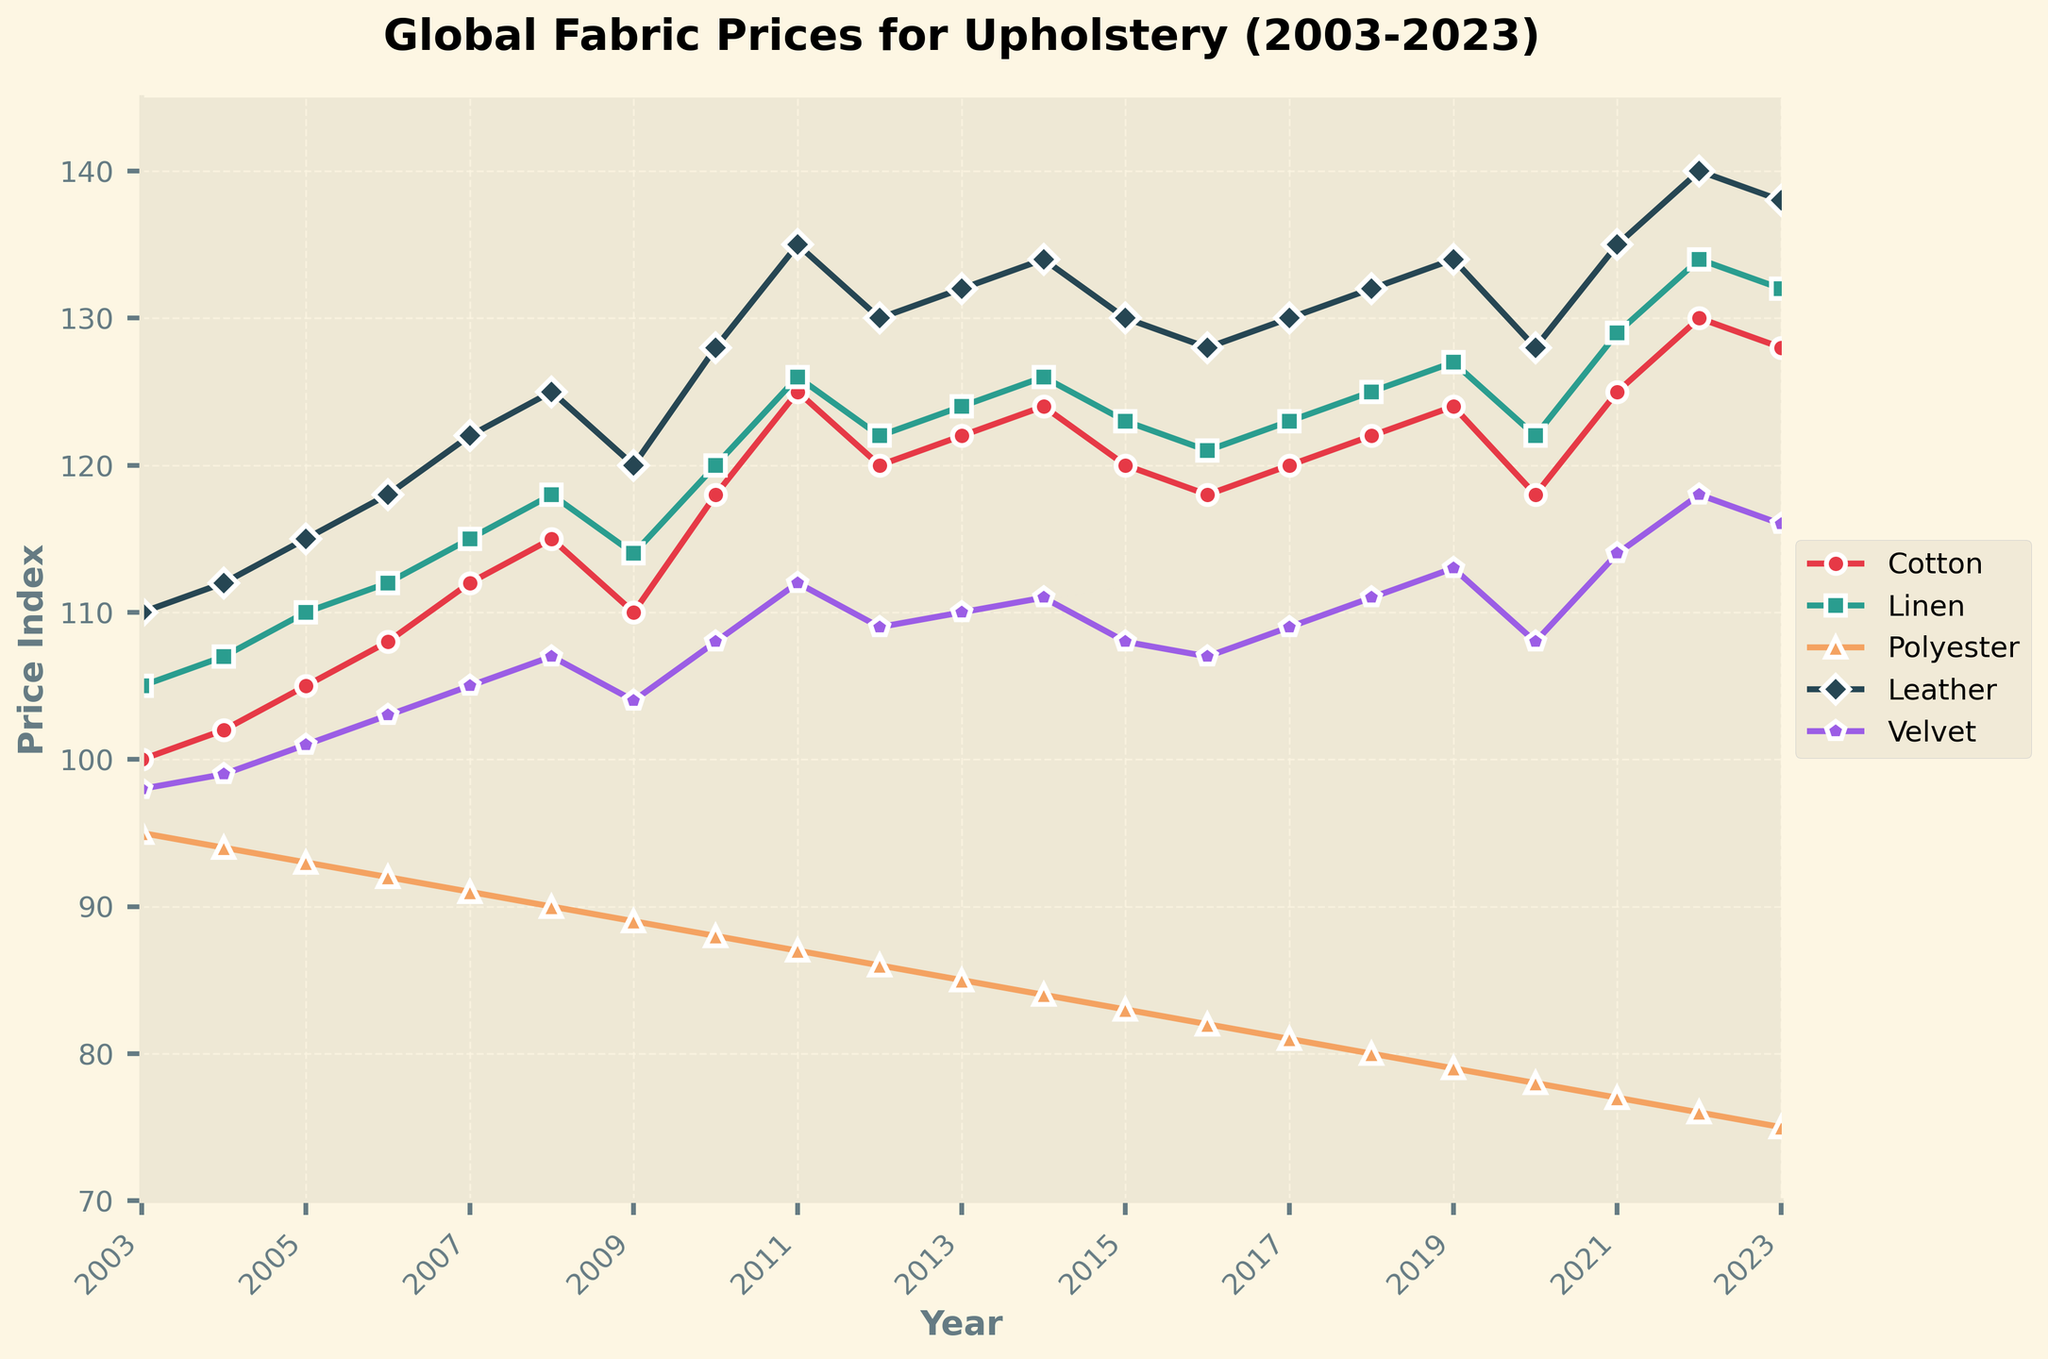Which fabric type had the highest price increase from 2003 to 2023? To answer this, observe the starting price in 2003 and the ending price in 2023 for each fabric type. The fabric with the most significant difference between these two years indicates the highest price increase.
Answer: Leather Which fabric had the most stable price over the last 20 years, showing the least fluctuations? Check the lines' consistency for each fabric type over the years. The fabric with the most stable line and the least variability has the most stable price.
Answer: Velvet In what year did cotton prices peak? Locate the peak point for the cotton line and find the corresponding year on the x-axis.
Answer: 2022 How do the prices of polyester in 2014 compare to those in 2017? Compare the values of polyester in 2014 and 2017 directly from the chart to see which year has a higher or lower price.
Answer: Lower Which fabric type showed a notable price decrease between 2011 and 2012? Examine the data for each fabric and look for the segment where a significant price drop occurs between 2011 and 2012.
Answer: Cotton What was the approximate price index for leather in 2010? Locate the data point for leather in 2010 on the chart and read the corresponding value on the y-axis.
Answer: 128 Which fabric type had its highest price in the year 2021? Check the highest value for each fabric type in the year 2021 and compare them to determine which one had the highest price.
Answer: Leather What is the average price index of velvet over the entire period from 2003 to 2023? Calculate the average by summing the velvet prices from 2003 to 2023 and dividing by the number of years (21). The sum is 2308, and the average is 2308/21.
Answer: 109.9 How did linen prices change between 2018 and 2019? Observe the linen prices in 2018 and 2019 and determine whether there was an increase or decrease.
Answer: Increase 